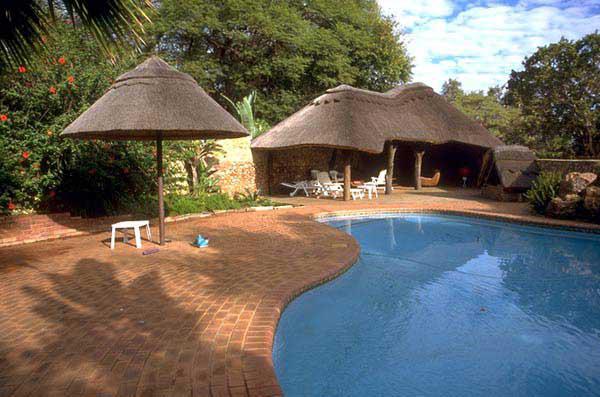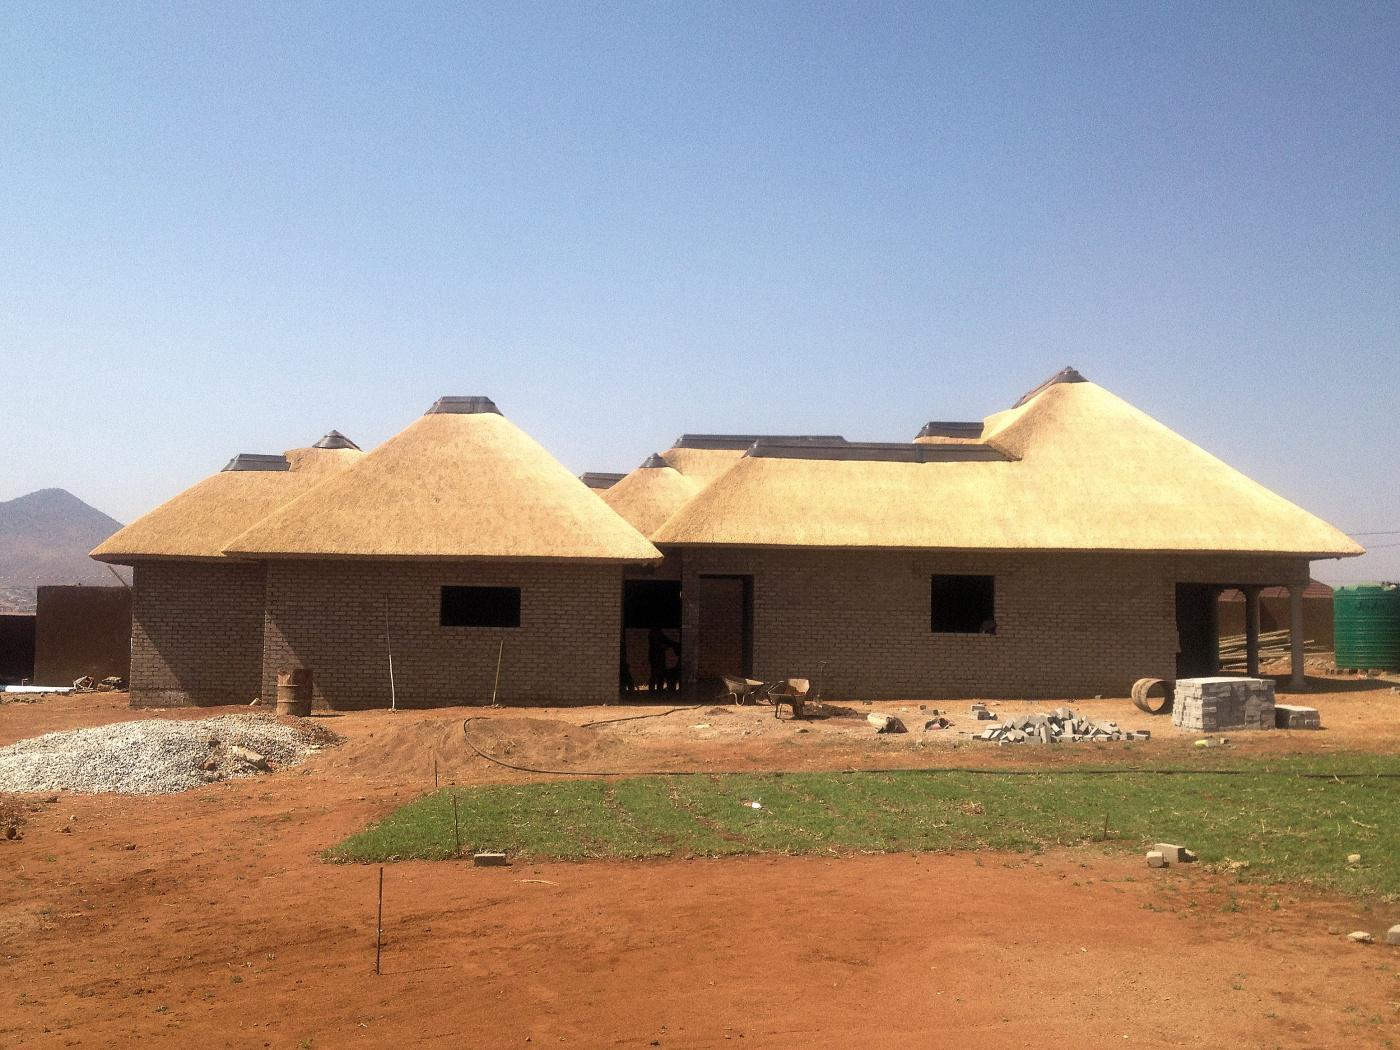The first image is the image on the left, the second image is the image on the right. For the images shown, is this caption "The right image shows an exterior with a bench to the right of a narrow rectangular pool, and behind the pool large glass doors with a chimney above them in front of a dark roof." true? Answer yes or no. No. The first image is the image on the left, the second image is the image on the right. For the images displayed, is the sentence "One of the houses is surrounded by a green lawn; it's not merely a small green field." factually correct? Answer yes or no. No. 